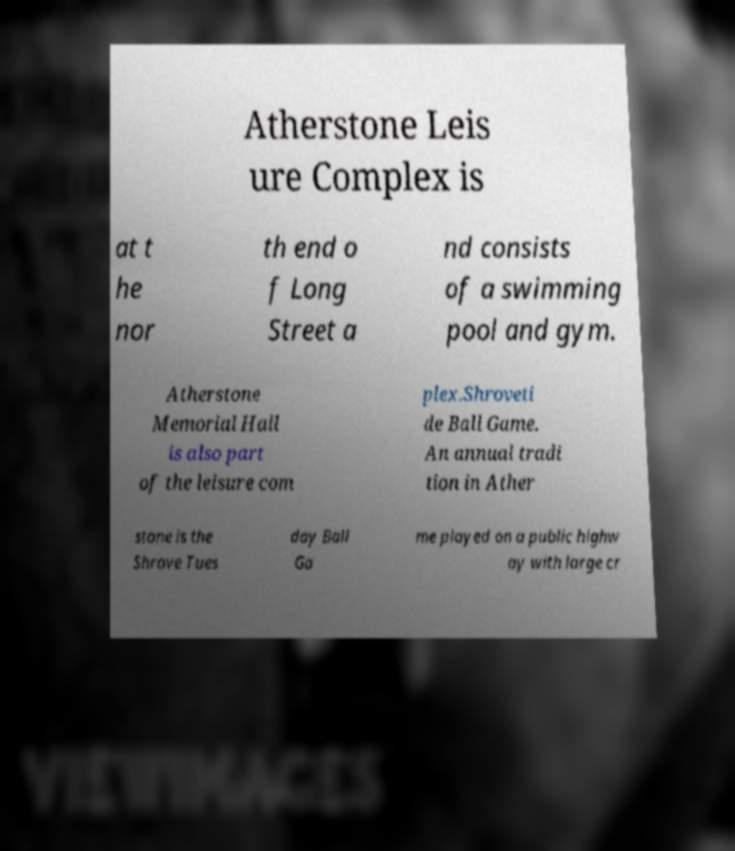Can you accurately transcribe the text from the provided image for me? Atherstone Leis ure Complex is at t he nor th end o f Long Street a nd consists of a swimming pool and gym. Atherstone Memorial Hall is also part of the leisure com plex.Shroveti de Ball Game. An annual tradi tion in Ather stone is the Shrove Tues day Ball Ga me played on a public highw ay with large cr 